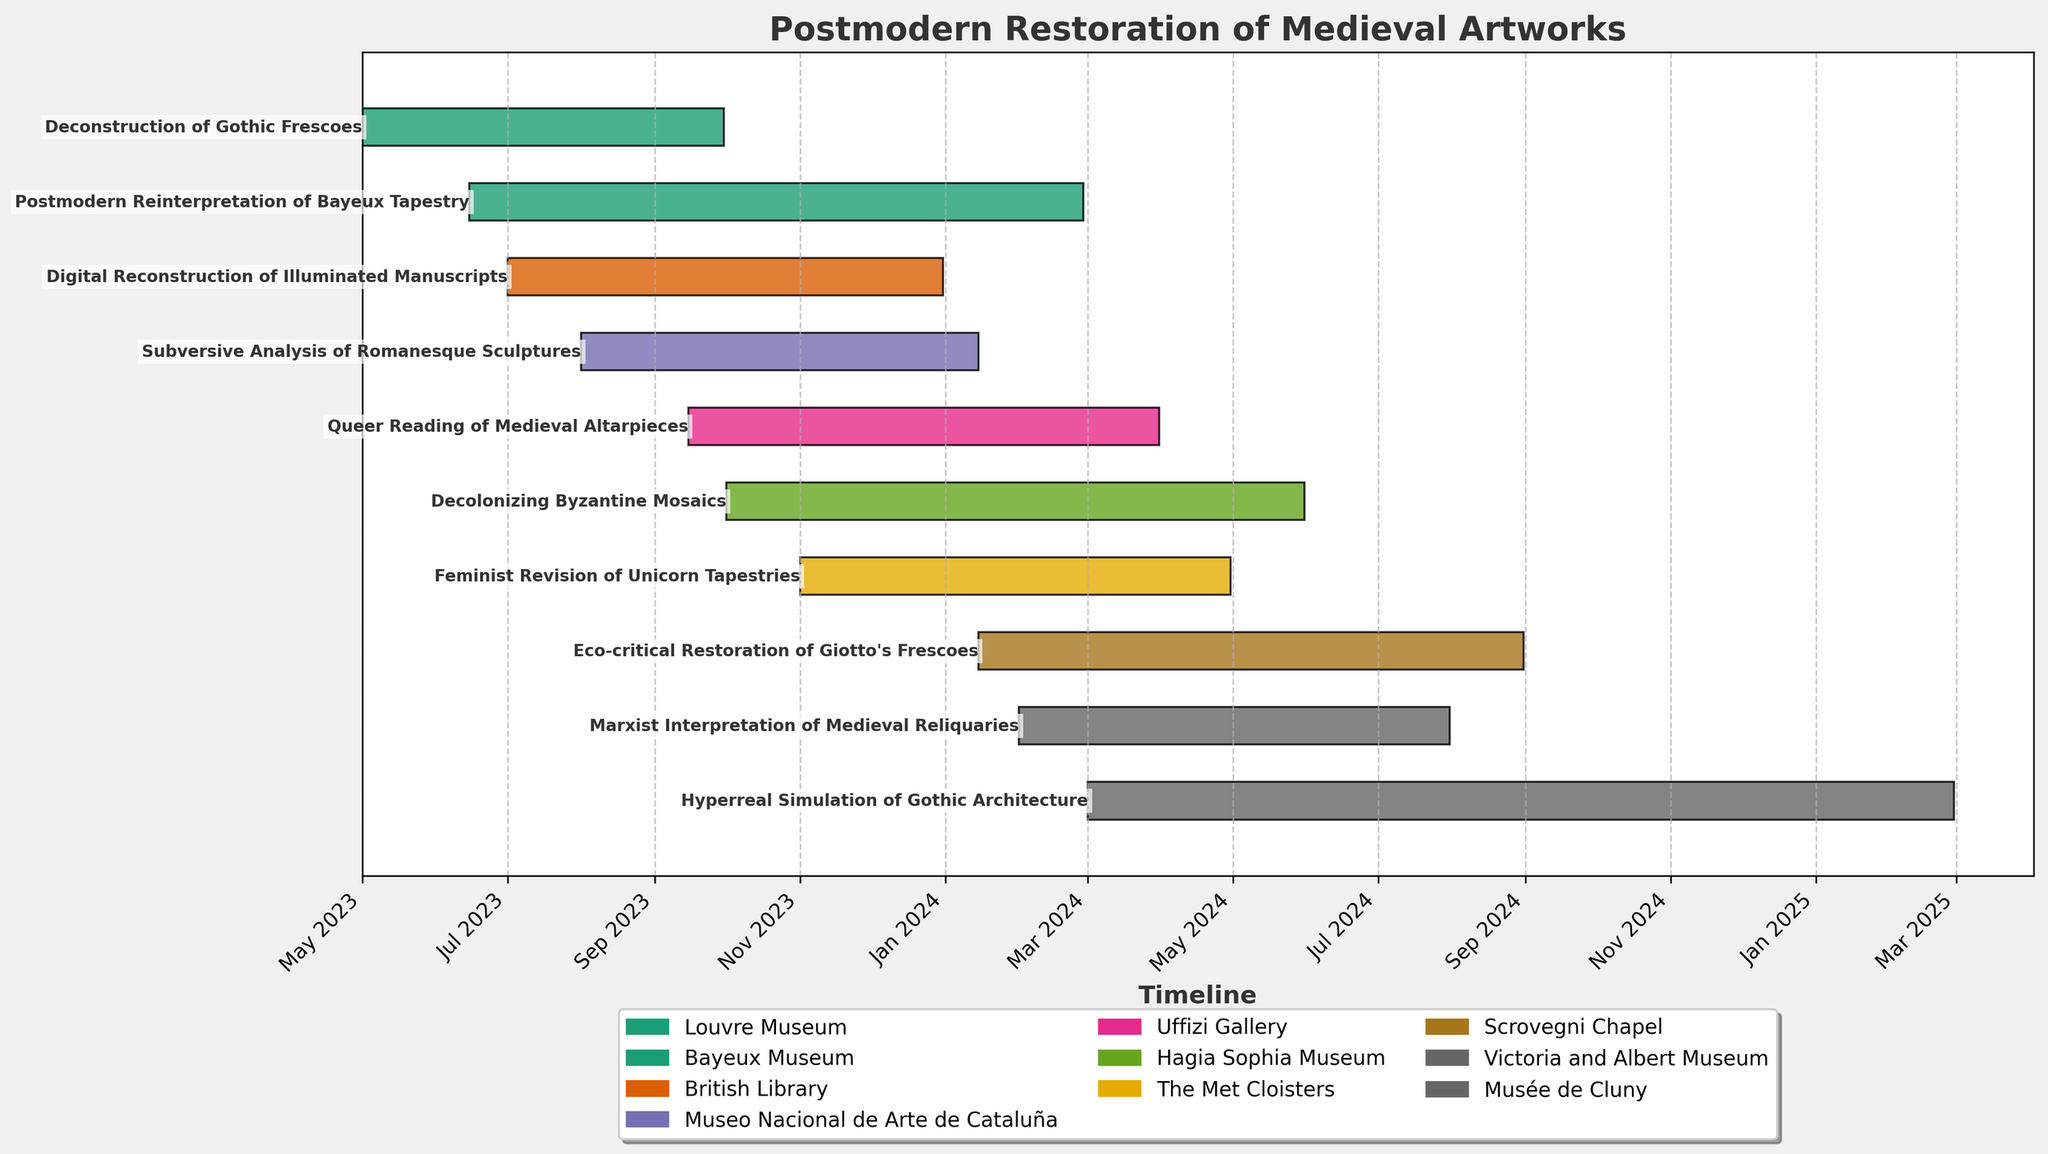How many tasks are scheduled to end in 2024? To determine the number of tasks ending in 2024, look at the end dates for all tasks. Count those that have an end date within the year 2024.
Answer: 8 Which museum has the most restoration projects? Count the number of tasks assigned to each museum by looking at the "Museum" labels in the tasks list. The museum with the highest count has the most projects.
Answer: Uffizi Gallery Which is the earliest task to start and the latest task to finish? Identify the task with the earliest start date and the task with the latest end date by visually checking the start and end points of the bars.
Answer: Earliest: Deconstruction of Gothic Frescoes, Latest: Hyperreal Simulation of Gothic Architecture Are there any tasks scheduled to start after January 2024? Check the start dates of all tasks and see if any of them are dated after January 2024.
Answer: Yes Which two museums have the tasks ending closest to each other in time? Compare the end dates of tasks and find two museums whose tasks end dates are closest.
Answer: Victoria and Albert Museum and The Met Cloisters How many months does the "Postmodern Reinterpretation of Bayeux Tapestry" project last? Calculate the duration by subtracting the start date from the end date and converting the difference into months.
Answer: About 8.5 months What is the average duration of the tasks in months? Calculate the duration of each task in months, sum them, and divide by the number of tasks.
Answer: ~8.6 months Which task overlaps the most with the "Feminist Revision of Unicorn Tapestries"? Compare the timelines of other tasks with the "Feminist Revision of Unicorn Tapestries" to see which one has the most overlapping period.
Answer: Queer Reading of Medieval Altarpieces Compare the start and end dates of "Eco-critical Restoration of Giotto's Frescoes" and "Marxist Interpretation of Medieval Reliquaries". Which starts earlier, and which ends later? Examine the start and end dates of both tasks to determine the one that starts earlier and the one that ends later.
Answer: Starts earlier: Eco-critical Restoration of Giotto's Frescoes, Ends later: Eco-critical Restoration of Giotto's Frescoes How many months does it take to complete all tasks in total, assuming no overlap? Sum the durations of all tasks in months to get the total time needed without considering overlaps.
Answer: 24 months 